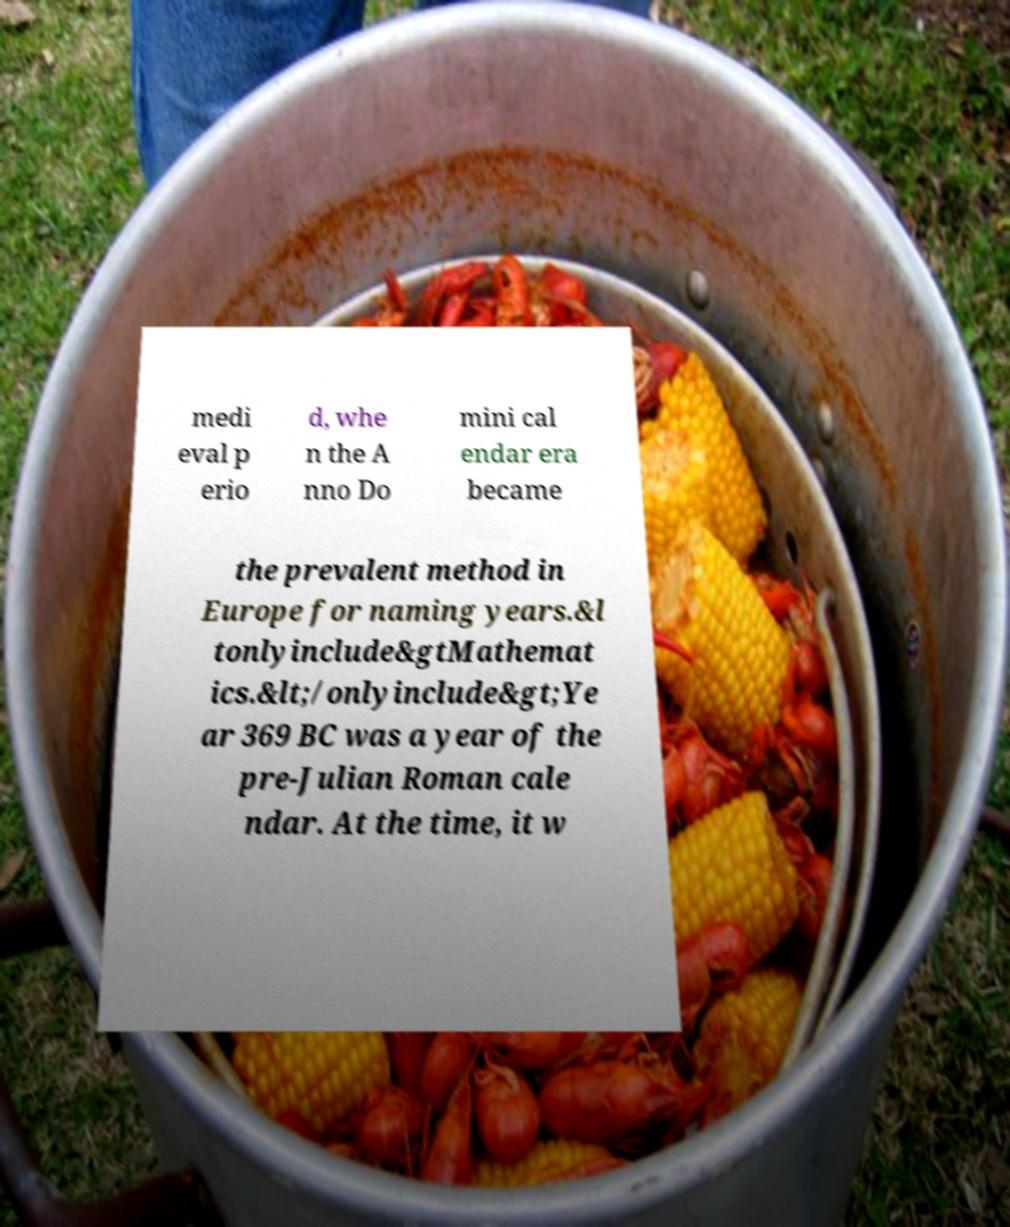Could you extract and type out the text from this image? medi eval p erio d, whe n the A nno Do mini cal endar era became the prevalent method in Europe for naming years.&l tonlyinclude&gtMathemat ics.&lt;/onlyinclude&gt;Ye ar 369 BC was a year of the pre-Julian Roman cale ndar. At the time, it w 